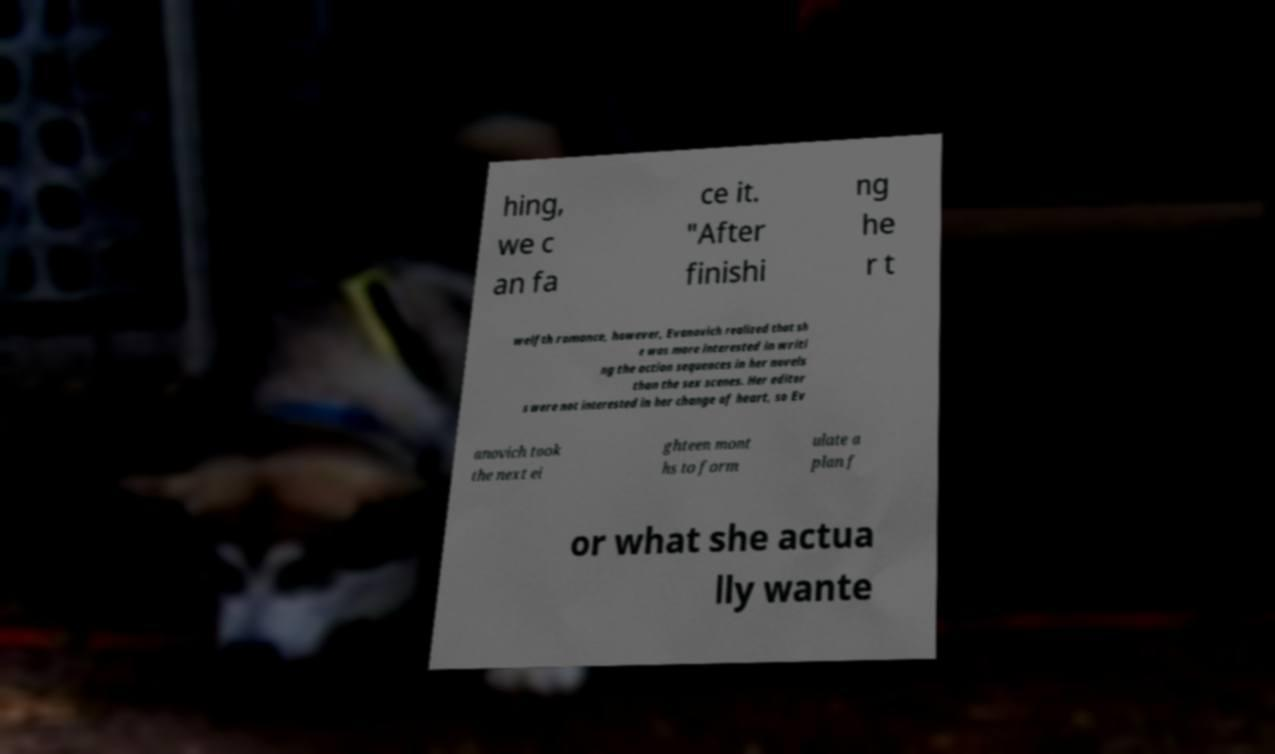I need the written content from this picture converted into text. Can you do that? hing, we c an fa ce it. "After finishi ng he r t welfth romance, however, Evanovich realized that sh e was more interested in writi ng the action sequences in her novels than the sex scenes. Her editor s were not interested in her change of heart, so Ev anovich took the next ei ghteen mont hs to form ulate a plan f or what she actua lly wante 